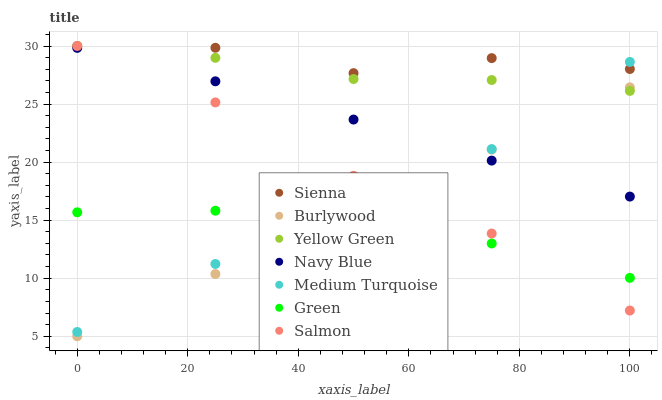Does Green have the minimum area under the curve?
Answer yes or no. Yes. Does Sienna have the maximum area under the curve?
Answer yes or no. Yes. Does Burlywood have the minimum area under the curve?
Answer yes or no. No. Does Burlywood have the maximum area under the curve?
Answer yes or no. No. Is Burlywood the smoothest?
Answer yes or no. Yes. Is Sienna the roughest?
Answer yes or no. Yes. Is Navy Blue the smoothest?
Answer yes or no. No. Is Navy Blue the roughest?
Answer yes or no. No. Does Burlywood have the lowest value?
Answer yes or no. Yes. Does Navy Blue have the lowest value?
Answer yes or no. No. Does Sienna have the highest value?
Answer yes or no. Yes. Does Burlywood have the highest value?
Answer yes or no. No. Is Navy Blue less than Sienna?
Answer yes or no. Yes. Is Medium Turquoise greater than Burlywood?
Answer yes or no. Yes. Does Navy Blue intersect Salmon?
Answer yes or no. Yes. Is Navy Blue less than Salmon?
Answer yes or no. No. Is Navy Blue greater than Salmon?
Answer yes or no. No. Does Navy Blue intersect Sienna?
Answer yes or no. No. 